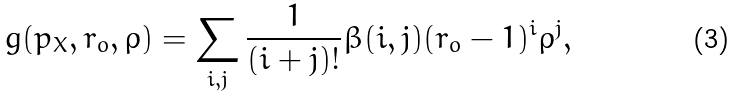<formula> <loc_0><loc_0><loc_500><loc_500>g ( p _ { X } , r _ { o } , \rho ) = \sum _ { i , j } \frac { 1 } { ( i + j ) ! } \beta ( i , j ) ( r _ { o } - 1 ) ^ { i } \rho ^ { j } ,</formula> 